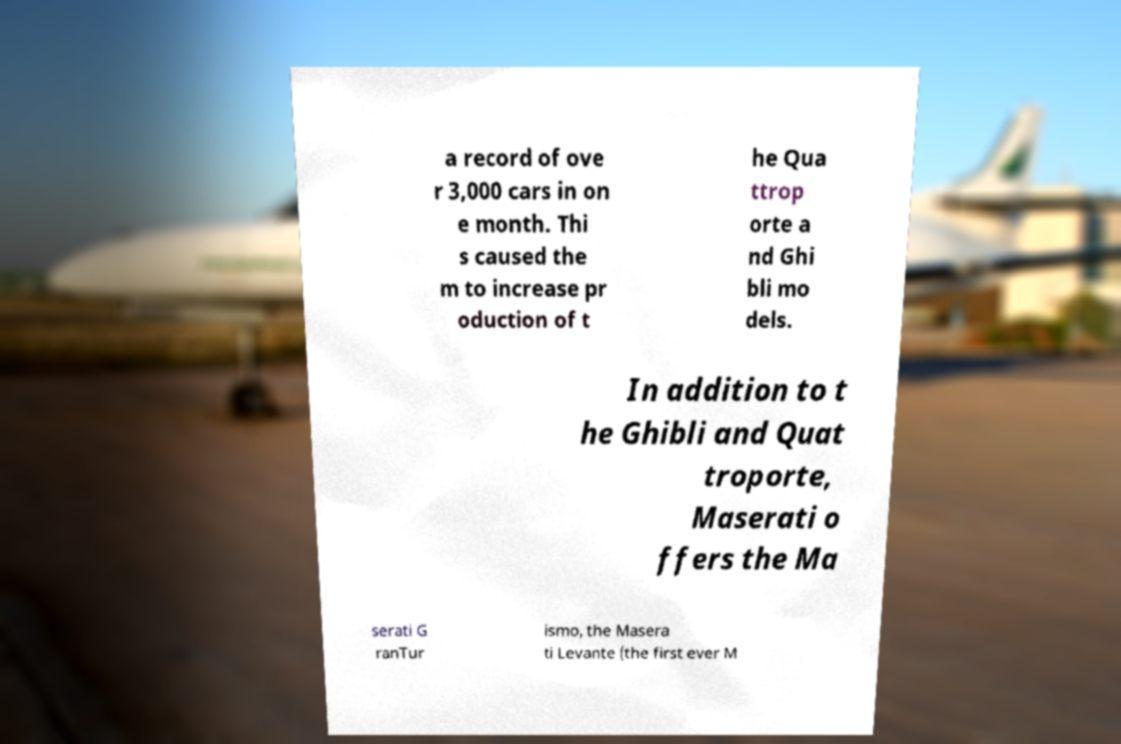I need the written content from this picture converted into text. Can you do that? a record of ove r 3,000 cars in on e month. Thi s caused the m to increase pr oduction of t he Qua ttrop orte a nd Ghi bli mo dels. In addition to t he Ghibli and Quat troporte, Maserati o ffers the Ma serati G ranTur ismo, the Masera ti Levante (the first ever M 